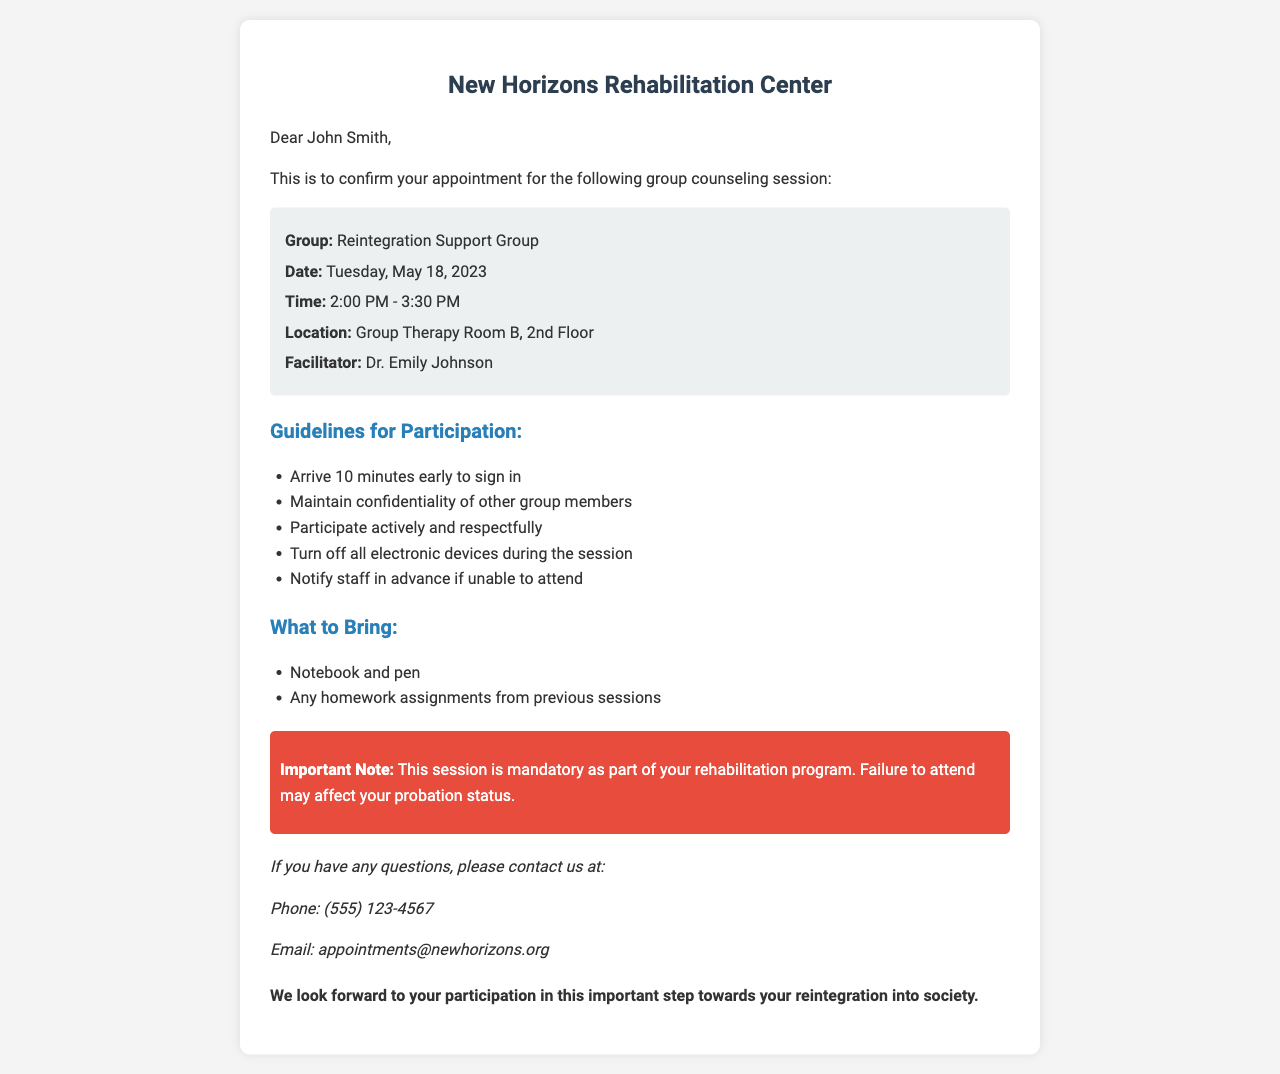What is the name of the group? The name of the group is stated in the appointment details section.
Answer: Reintegration Support Group What is the date of the counseling session? The date is provided in the appointment details.
Answer: Tuesday, May 18, 2023 What is the time for the counseling session? The time can be found in the appointment details.
Answer: 2:00 PM - 3:30 PM Who is the facilitator for the session? The facilitator's name is mentioned in the appointment details.
Answer: Dr. Emily Johnson What should participants bring to the session? The document lists items participants are asked to bring.
Answer: Notebook and pen Why is this session considered mandatory? The reason for mandatory attendance is explained in the important note.
Answer: Affects probation status How many minutes early should participants arrive? The guideline specifies how early attendees should arrive.
Answer: 10 minutes What should participants do with electronic devices during the session? The guideline informs about the expected behavior towards electronic devices.
Answer: Turn off How should participants handle confidentiality? The guideline advises on maintaining group member confidentiality.
Answer: Maintain confidentiality What should someone do if they cannot attend? The guideline states what participants need to do if unable to attend.
Answer: Notify staff in advance 